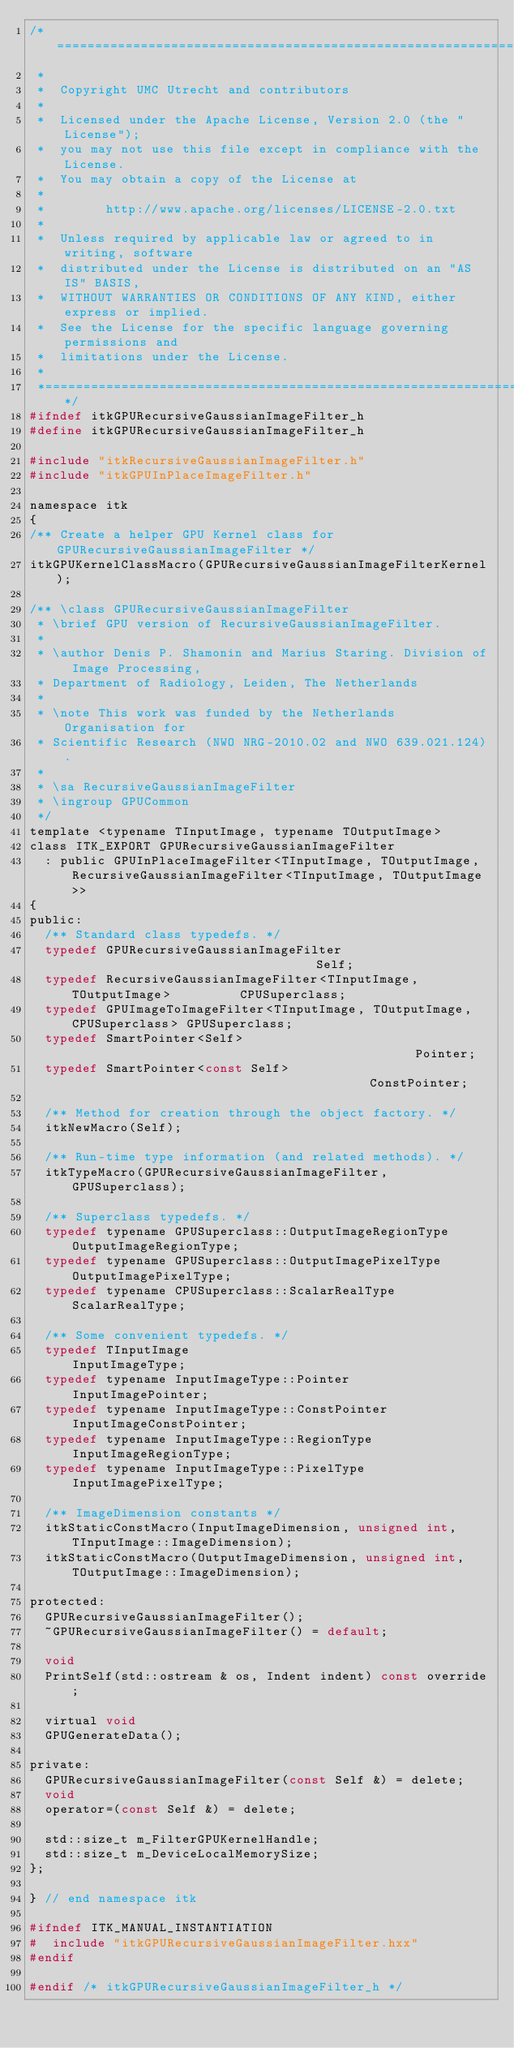<code> <loc_0><loc_0><loc_500><loc_500><_C_>/*=========================================================================
 *
 *  Copyright UMC Utrecht and contributors
 *
 *  Licensed under the Apache License, Version 2.0 (the "License");
 *  you may not use this file except in compliance with the License.
 *  You may obtain a copy of the License at
 *
 *        http://www.apache.org/licenses/LICENSE-2.0.txt
 *
 *  Unless required by applicable law or agreed to in writing, software
 *  distributed under the License is distributed on an "AS IS" BASIS,
 *  WITHOUT WARRANTIES OR CONDITIONS OF ANY KIND, either express or implied.
 *  See the License for the specific language governing permissions and
 *  limitations under the License.
 *
 *=========================================================================*/
#ifndef itkGPURecursiveGaussianImageFilter_h
#define itkGPURecursiveGaussianImageFilter_h

#include "itkRecursiveGaussianImageFilter.h"
#include "itkGPUInPlaceImageFilter.h"

namespace itk
{
/** Create a helper GPU Kernel class for GPURecursiveGaussianImageFilter */
itkGPUKernelClassMacro(GPURecursiveGaussianImageFilterKernel);

/** \class GPURecursiveGaussianImageFilter
 * \brief GPU version of RecursiveGaussianImageFilter.
 *
 * \author Denis P. Shamonin and Marius Staring. Division of Image Processing,
 * Department of Radiology, Leiden, The Netherlands
 *
 * \note This work was funded by the Netherlands Organisation for
 * Scientific Research (NWO NRG-2010.02 and NWO 639.021.124).
 *
 * \sa RecursiveGaussianImageFilter
 * \ingroup GPUCommon
 */
template <typename TInputImage, typename TOutputImage>
class ITK_EXPORT GPURecursiveGaussianImageFilter
  : public GPUInPlaceImageFilter<TInputImage, TOutputImage, RecursiveGaussianImageFilter<TInputImage, TOutputImage>>
{
public:
  /** Standard class typedefs. */
  typedef GPURecursiveGaussianImageFilter                                 Self;
  typedef RecursiveGaussianImageFilter<TInputImage, TOutputImage>         CPUSuperclass;
  typedef GPUImageToImageFilter<TInputImage, TOutputImage, CPUSuperclass> GPUSuperclass;
  typedef SmartPointer<Self>                                              Pointer;
  typedef SmartPointer<const Self>                                        ConstPointer;

  /** Method for creation through the object factory. */
  itkNewMacro(Self);

  /** Run-time type information (and related methods). */
  itkTypeMacro(GPURecursiveGaussianImageFilter, GPUSuperclass);

  /** Superclass typedefs. */
  typedef typename GPUSuperclass::OutputImageRegionType OutputImageRegionType;
  typedef typename GPUSuperclass::OutputImagePixelType  OutputImagePixelType;
  typedef typename CPUSuperclass::ScalarRealType        ScalarRealType;

  /** Some convenient typedefs. */
  typedef TInputImage                           InputImageType;
  typedef typename InputImageType::Pointer      InputImagePointer;
  typedef typename InputImageType::ConstPointer InputImageConstPointer;
  typedef typename InputImageType::RegionType   InputImageRegionType;
  typedef typename InputImageType::PixelType    InputImagePixelType;

  /** ImageDimension constants */
  itkStaticConstMacro(InputImageDimension, unsigned int, TInputImage::ImageDimension);
  itkStaticConstMacro(OutputImageDimension, unsigned int, TOutputImage::ImageDimension);

protected:
  GPURecursiveGaussianImageFilter();
  ~GPURecursiveGaussianImageFilter() = default;

  void
  PrintSelf(std::ostream & os, Indent indent) const override;

  virtual void
  GPUGenerateData();

private:
  GPURecursiveGaussianImageFilter(const Self &) = delete;
  void
  operator=(const Self &) = delete;

  std::size_t m_FilterGPUKernelHandle;
  std::size_t m_DeviceLocalMemorySize;
};

} // end namespace itk

#ifndef ITK_MANUAL_INSTANTIATION
#  include "itkGPURecursiveGaussianImageFilter.hxx"
#endif

#endif /* itkGPURecursiveGaussianImageFilter_h */
</code> 